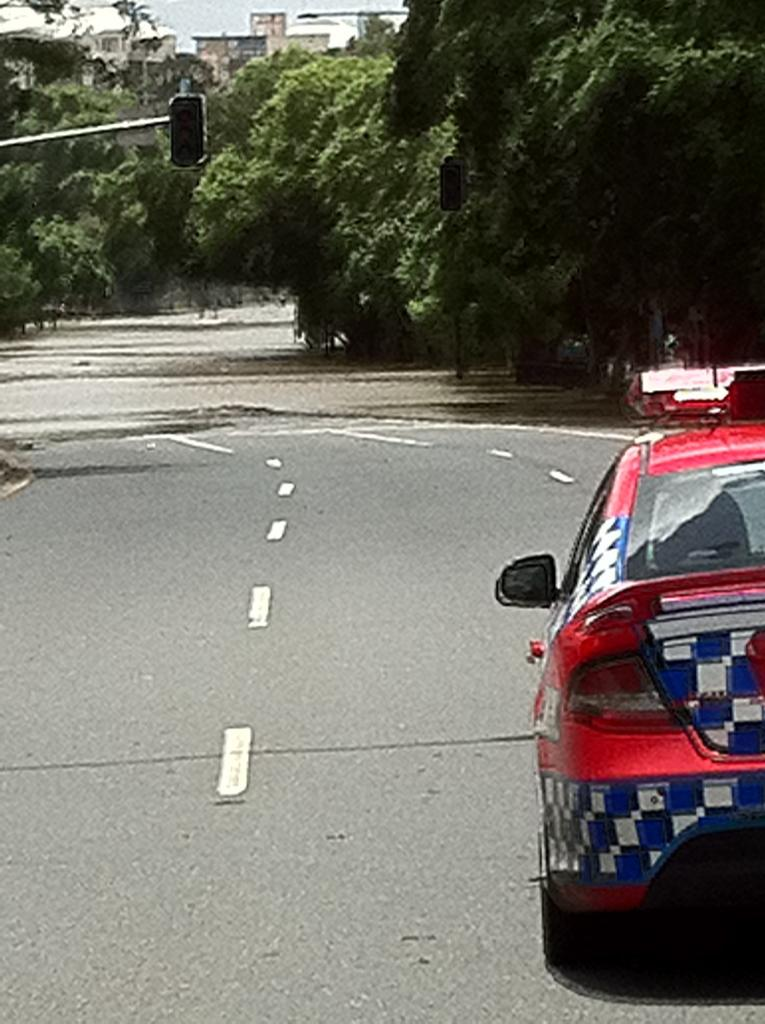What type of natural elements can be seen in the image? There are trees in the image. What type of man-made object can be seen on the road in the image? There is a red color vehicle visible on the road in the image. What type of star can be seen in the image? There is no star visible in the image; it only features trees and a red vehicle on the road. What kind of apparatus is being used by the trees in the image? There is no apparatus being used by the trees in the image; they are simply standing in their natural state. 